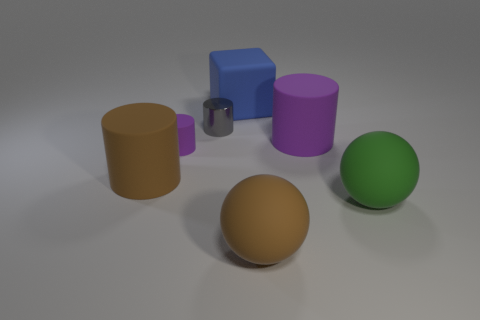Subtract 1 cylinders. How many cylinders are left? 3 Add 2 tiny blue matte cylinders. How many objects exist? 9 Subtract all blocks. How many objects are left? 6 Add 5 green metal things. How many green metal things exist? 5 Subtract 0 yellow blocks. How many objects are left? 7 Subtract all green things. Subtract all large purple metallic cylinders. How many objects are left? 6 Add 5 small purple cylinders. How many small purple cylinders are left? 6 